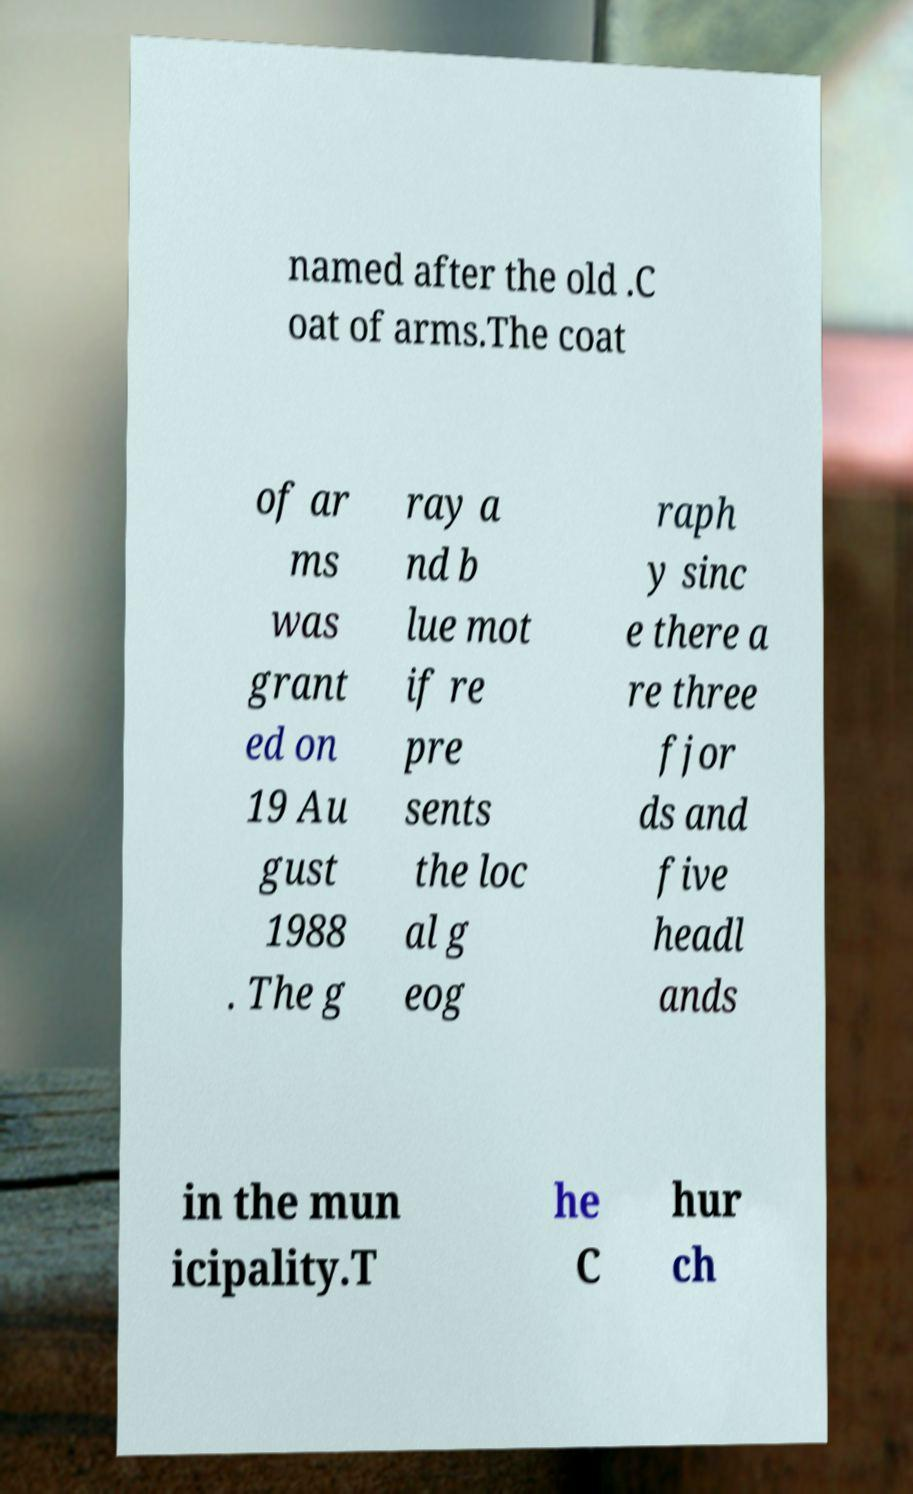Please read and relay the text visible in this image. What does it say? named after the old .C oat of arms.The coat of ar ms was grant ed on 19 Au gust 1988 . The g ray a nd b lue mot if re pre sents the loc al g eog raph y sinc e there a re three fjor ds and five headl ands in the mun icipality.T he C hur ch 